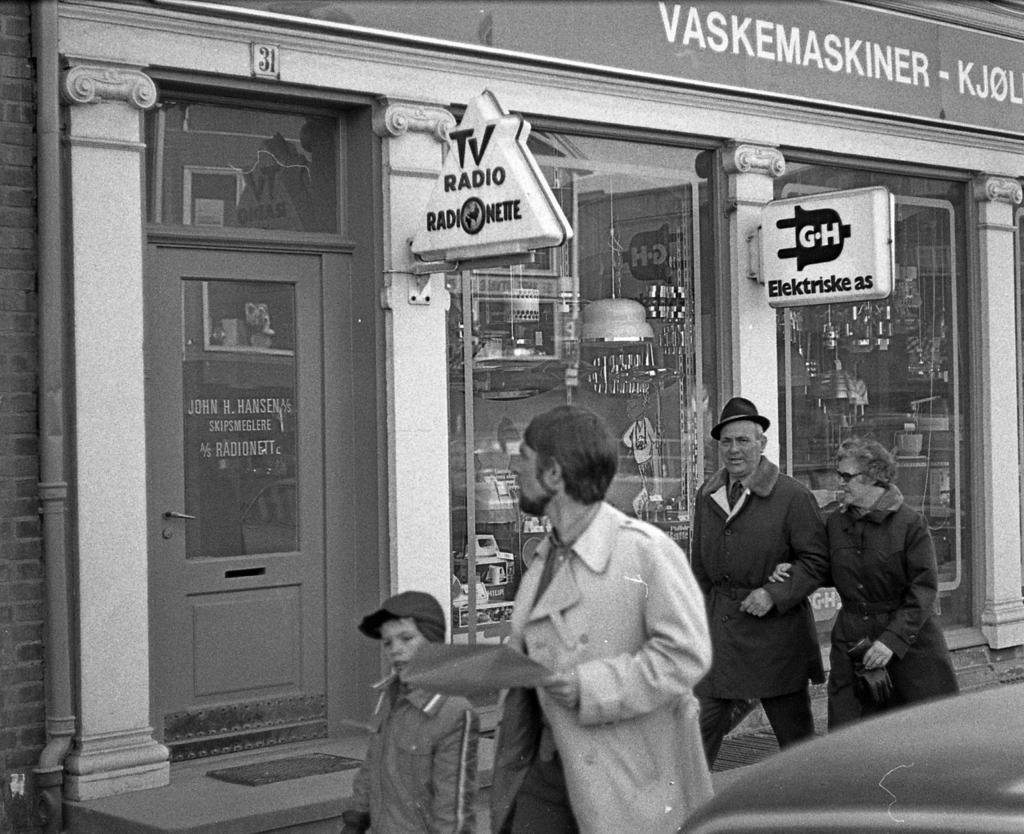Could you give a brief overview of what you see in this image? In the center of the image we can see people walking. In the background there is a building and we can see boards. There are pipes. 